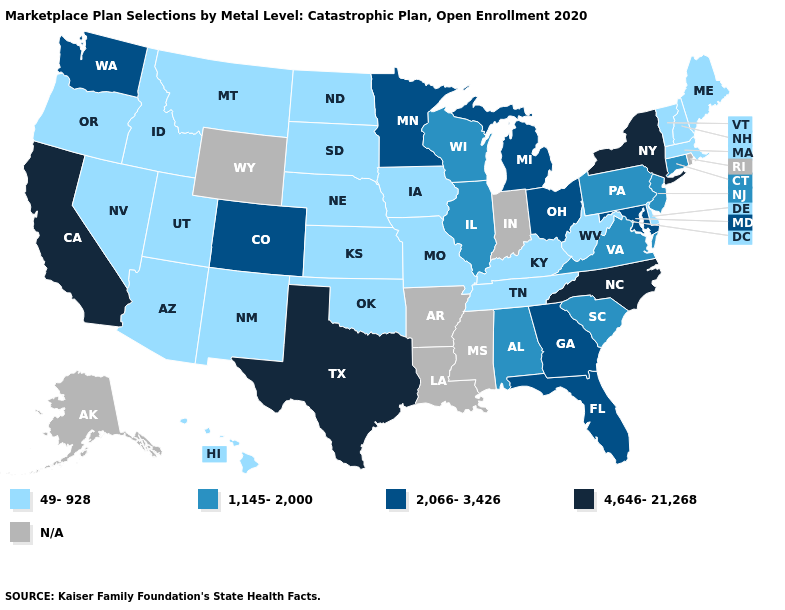Name the states that have a value in the range 4,646-21,268?
Answer briefly. California, New York, North Carolina, Texas. Does Texas have the highest value in the USA?
Write a very short answer. Yes. What is the highest value in states that border Wyoming?
Quick response, please. 2,066-3,426. What is the highest value in the West ?
Be succinct. 4,646-21,268. Name the states that have a value in the range 49-928?
Answer briefly. Arizona, Delaware, Hawaii, Idaho, Iowa, Kansas, Kentucky, Maine, Massachusetts, Missouri, Montana, Nebraska, Nevada, New Hampshire, New Mexico, North Dakota, Oklahoma, Oregon, South Dakota, Tennessee, Utah, Vermont, West Virginia. Among the states that border Florida , which have the lowest value?
Short answer required. Alabama. What is the value of Arizona?
Quick response, please. 49-928. Which states hav the highest value in the MidWest?
Answer briefly. Michigan, Minnesota, Ohio. Name the states that have a value in the range 1,145-2,000?
Short answer required. Alabama, Connecticut, Illinois, New Jersey, Pennsylvania, South Carolina, Virginia, Wisconsin. Which states have the lowest value in the South?
Keep it brief. Delaware, Kentucky, Oklahoma, Tennessee, West Virginia. Does Texas have the highest value in the USA?
Keep it brief. Yes. What is the highest value in the USA?
Quick response, please. 4,646-21,268. Name the states that have a value in the range 1,145-2,000?
Write a very short answer. Alabama, Connecticut, Illinois, New Jersey, Pennsylvania, South Carolina, Virginia, Wisconsin. Does the first symbol in the legend represent the smallest category?
Write a very short answer. Yes. 